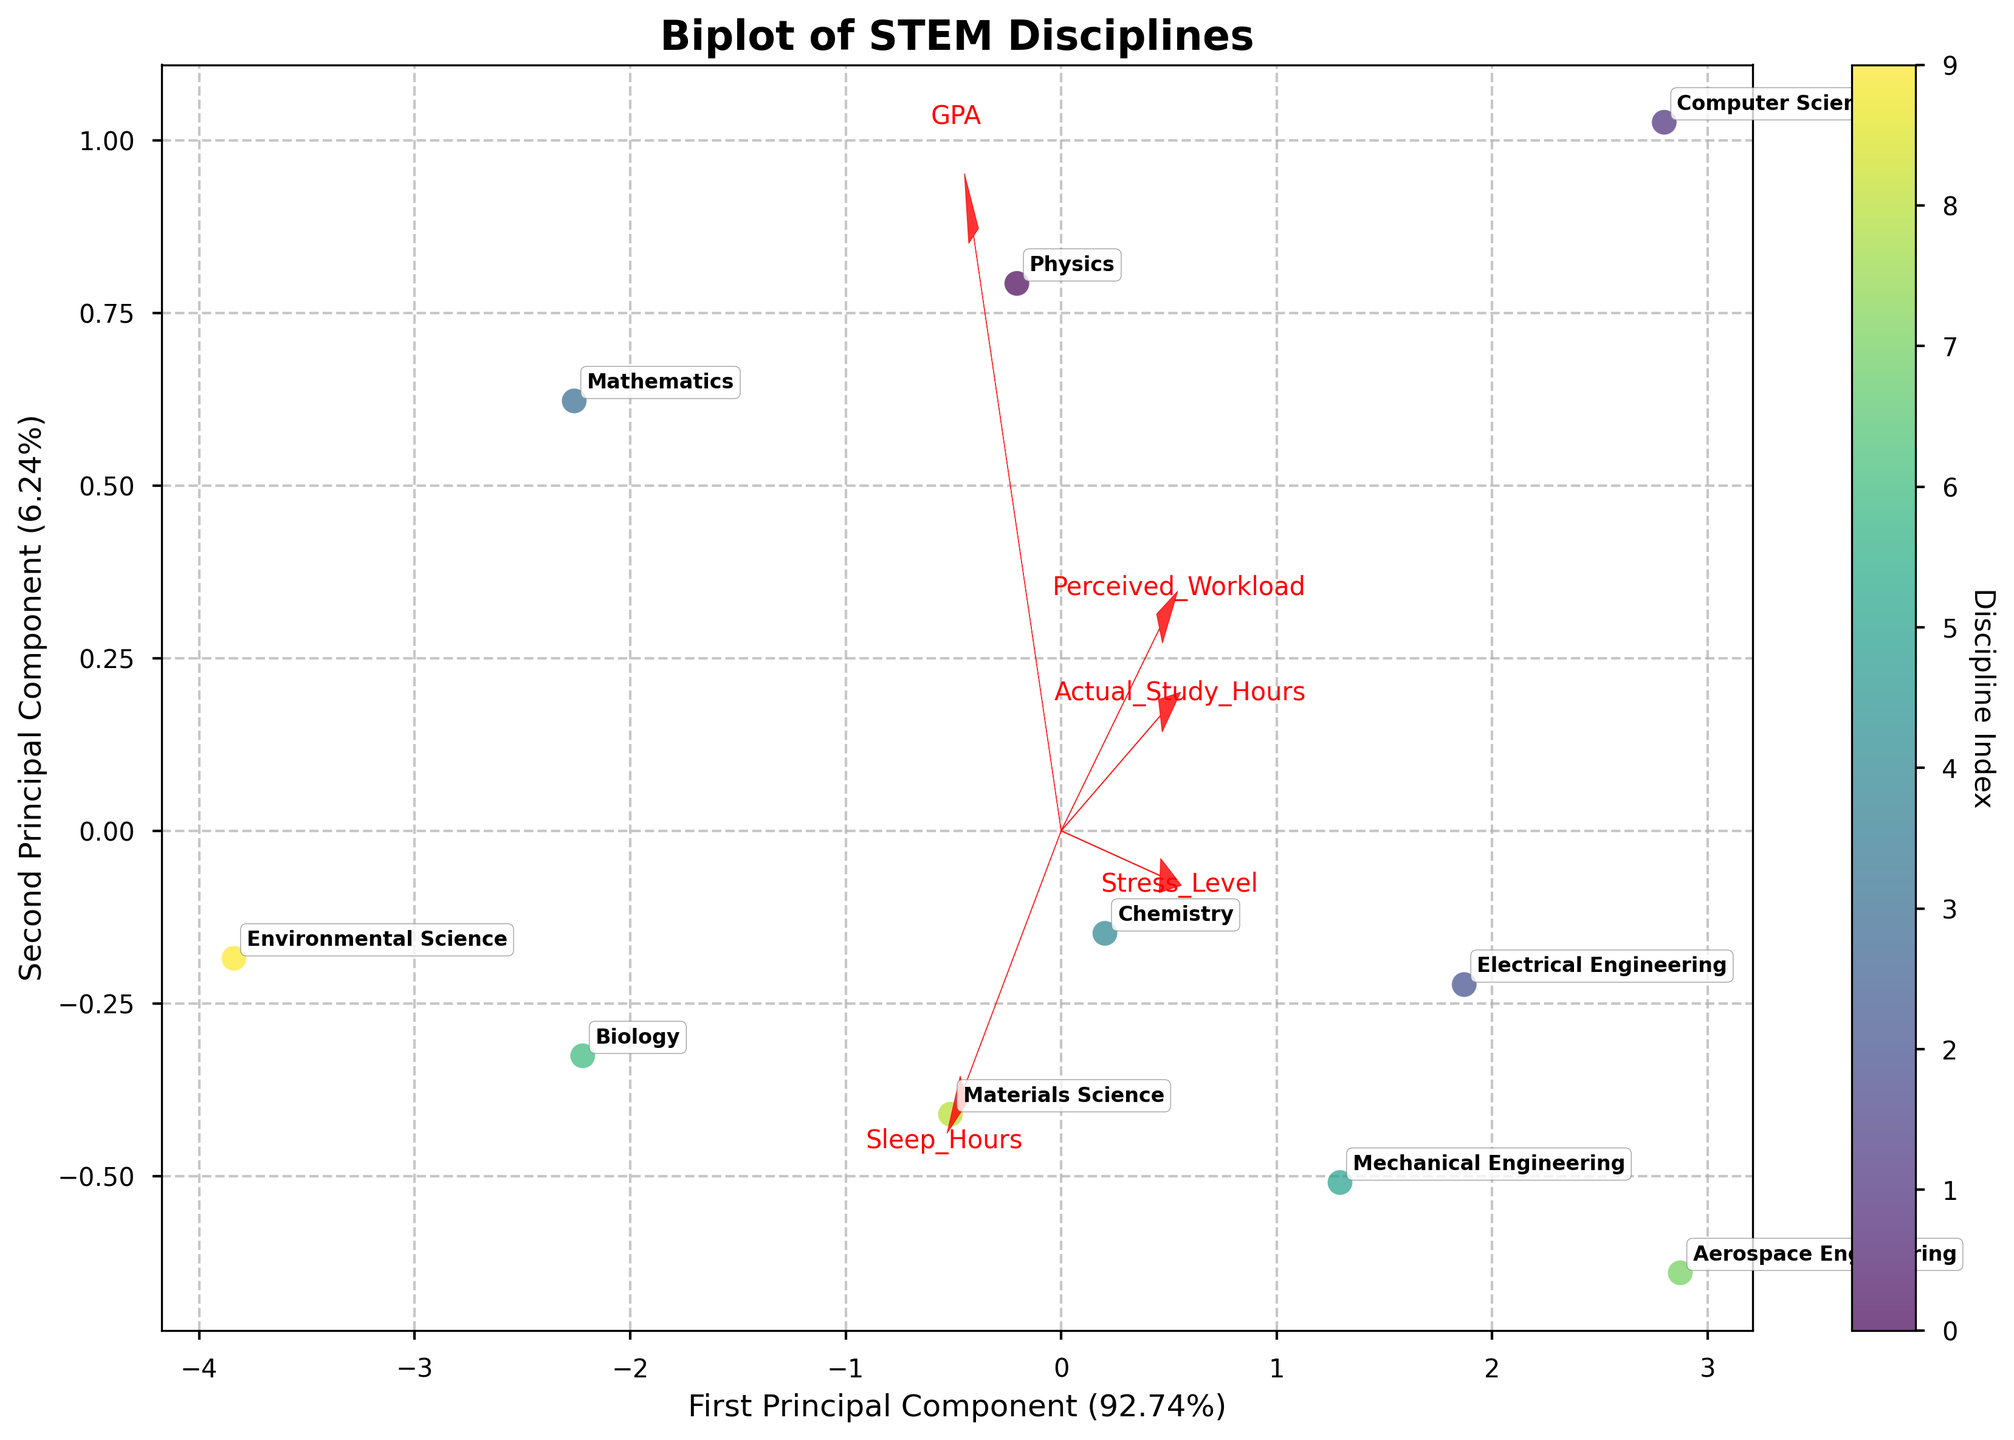What is the title of the figure? The title is usually displayed prominently at the top of the figure. From the data and code provided, the title given to the plot is "Biplot of STEM Disciplines".
Answer: Biplot of STEM Disciplines How many STEM disciplines are represented in the figure? By counting the labels used in the scatter plot annotations, we can determine the number of STEM disciplines. Each discipline appears as a unique annotation in the figure.
Answer: 10 What do the arrows in the figure represent? The arrows represent feature vectors of the original variables in the principal component space. They show the direction and magnitude of each feature's contribution to the principal components.
Answer: Feature vectors Which two disciplines have the highest perceived workload and actual study hours? The points for each discipline will be closest to the vectors labeled "Perceived_Workload" and "Actual_Study_Hours". These disciplines will be positioned in the direction these vectors point.
Answer: Computer Science and Aerospace Engineering Which discipline appears to have the highest GPA? The point for the discipline will be closest to the vector labeled "GPA". This discipline should be positioned in the direction this vector points.
Answer: Mathematics Which principal component explains more variance in the data? Principal components' explained variance ratios are usually indicated in the axis labels, with the percentage value showing their contribution. The one with the higher percentage explains more variance.
Answer: First Principal Component What is the relationship between stress level and sleep hours according to the biplot? The relationship can be inferred by observing the direction of the vectors for "Stress_Level" and "Sleep_Hours". Opposite directions imply a negative correlation, while similar directions imply a positive correlation.
Answer: Negative correlation Which discipline seems to have the least stress level? The discipline with the point farthest in the direction opposite to the "Stress_Level" vector likely indicates lower stress levels. Find the discipline label corresponding to this point.
Answer: Environmental Science Compare the sleep hours between Mechanical Engineering and Biology. Which discipline has higher sleep hours? Locate the points corresponding to Mechanical Engineering and Biology. Compare their positions relative to the "Sleep_Hours" vector direction; the point closer to this vector indicates higher sleep hours.
Answer: Biology How does perceived workload compare between Chemistry and Mathematics? Find the points for Chemistry and Mathematics. Determine their positions relative to the "Perceived_Workload" vector to see which is closer and, therefore, higher.
Answer: Chemistry has a higher perceived workload 